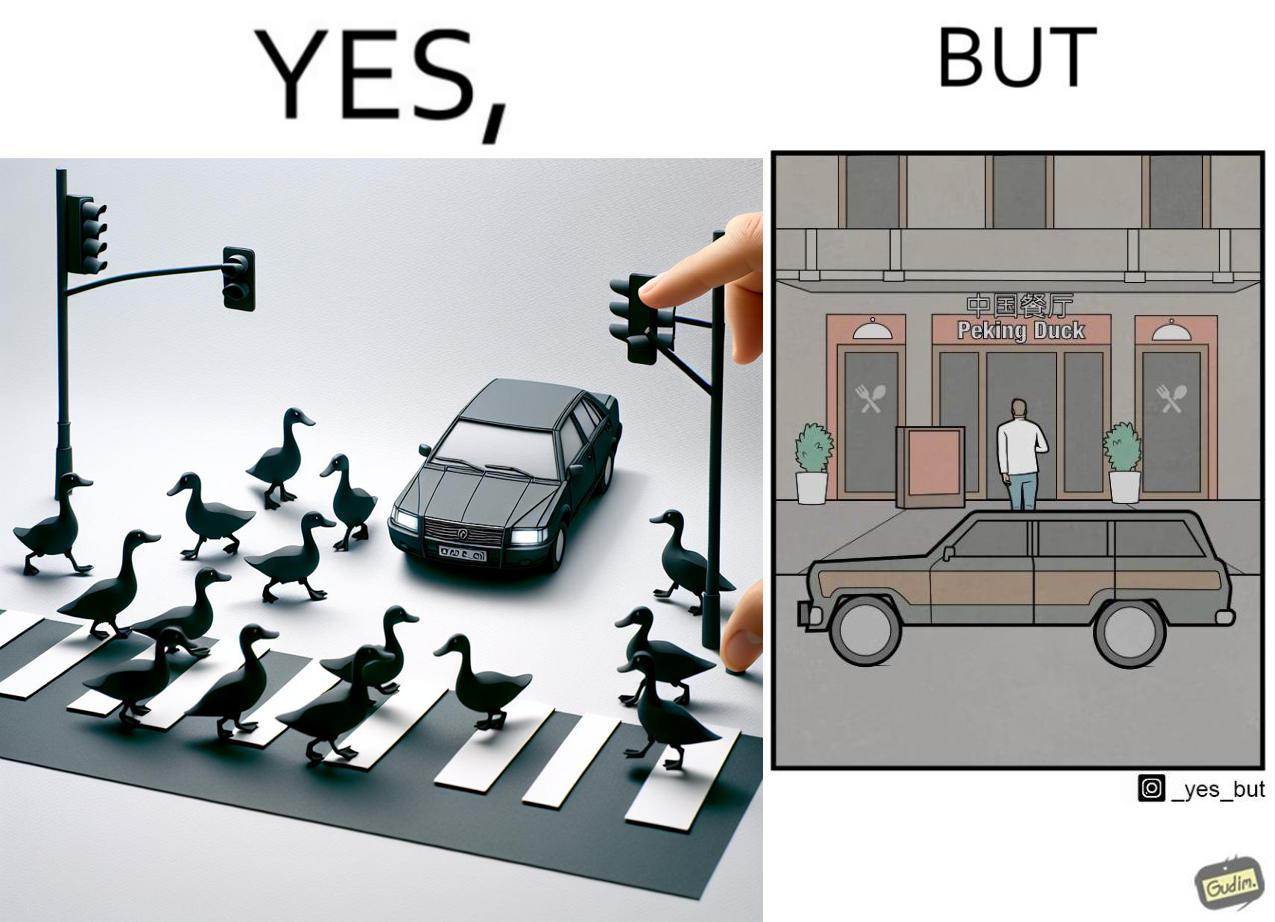What makes this image funny or satirical? The images are ironic since they show how a man supposedly cares for ducks since he stops his vehicle to give way to queue of ducks allowing them to safely cross a road but on the other hand he goes to a peking duck shop to buy and eat similar ducks after having them killed 